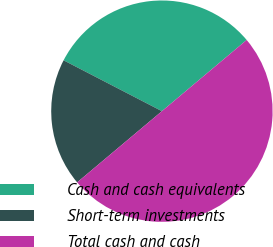Convert chart to OTSL. <chart><loc_0><loc_0><loc_500><loc_500><pie_chart><fcel>Cash and cash equivalents<fcel>Short-term investments<fcel>Total cash and cash<nl><fcel>31.28%<fcel>18.72%<fcel>50.0%<nl></chart> 